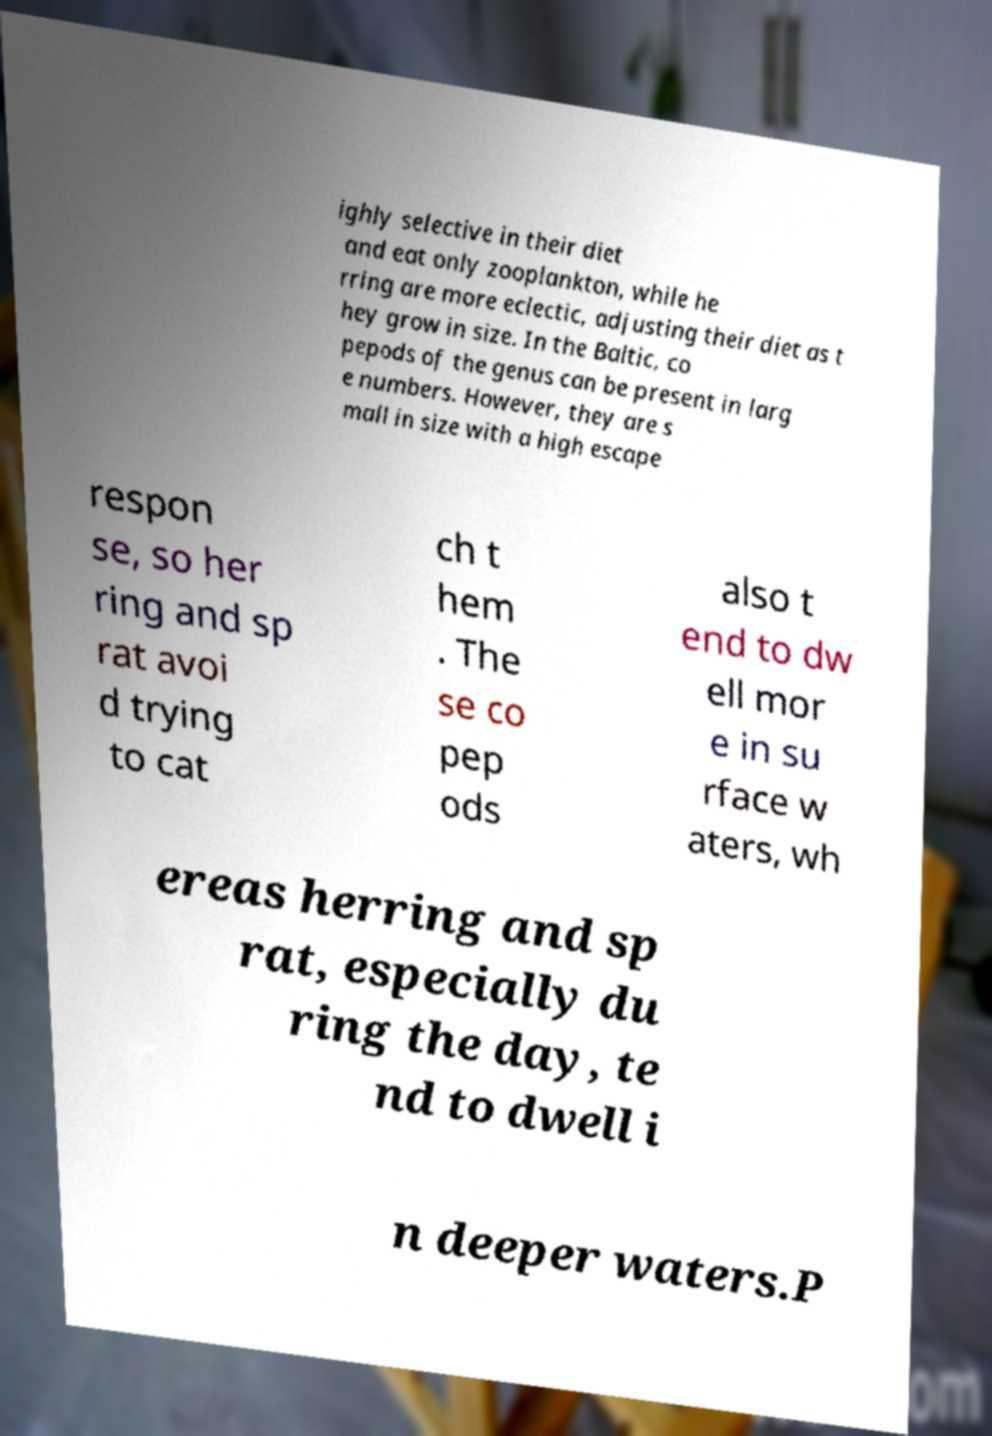I need the written content from this picture converted into text. Can you do that? ighly selective in their diet and eat only zooplankton, while he rring are more eclectic, adjusting their diet as t hey grow in size. In the Baltic, co pepods of the genus can be present in larg e numbers. However, they are s mall in size with a high escape respon se, so her ring and sp rat avoi d trying to cat ch t hem . The se co pep ods also t end to dw ell mor e in su rface w aters, wh ereas herring and sp rat, especially du ring the day, te nd to dwell i n deeper waters.P 